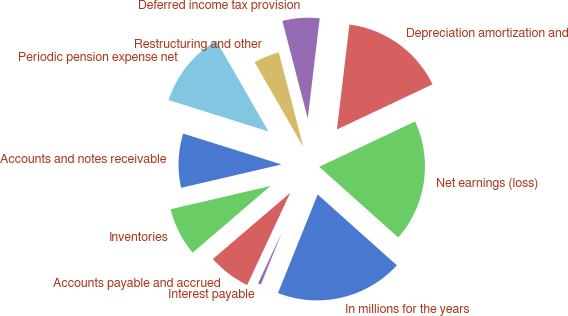Convert chart. <chart><loc_0><loc_0><loc_500><loc_500><pie_chart><fcel>In millions for the years<fcel>Net earnings (loss)<fcel>Depreciation amortization and<fcel>Deferred income tax provision<fcel>Restructuring and other<fcel>Periodic pension expense net<fcel>Accounts and notes receivable<fcel>Inventories<fcel>Accounts payable and accrued<fcel>Interest payable<nl><fcel>19.48%<fcel>18.63%<fcel>16.09%<fcel>5.94%<fcel>4.25%<fcel>11.86%<fcel>8.48%<fcel>7.63%<fcel>6.78%<fcel>0.86%<nl></chart> 